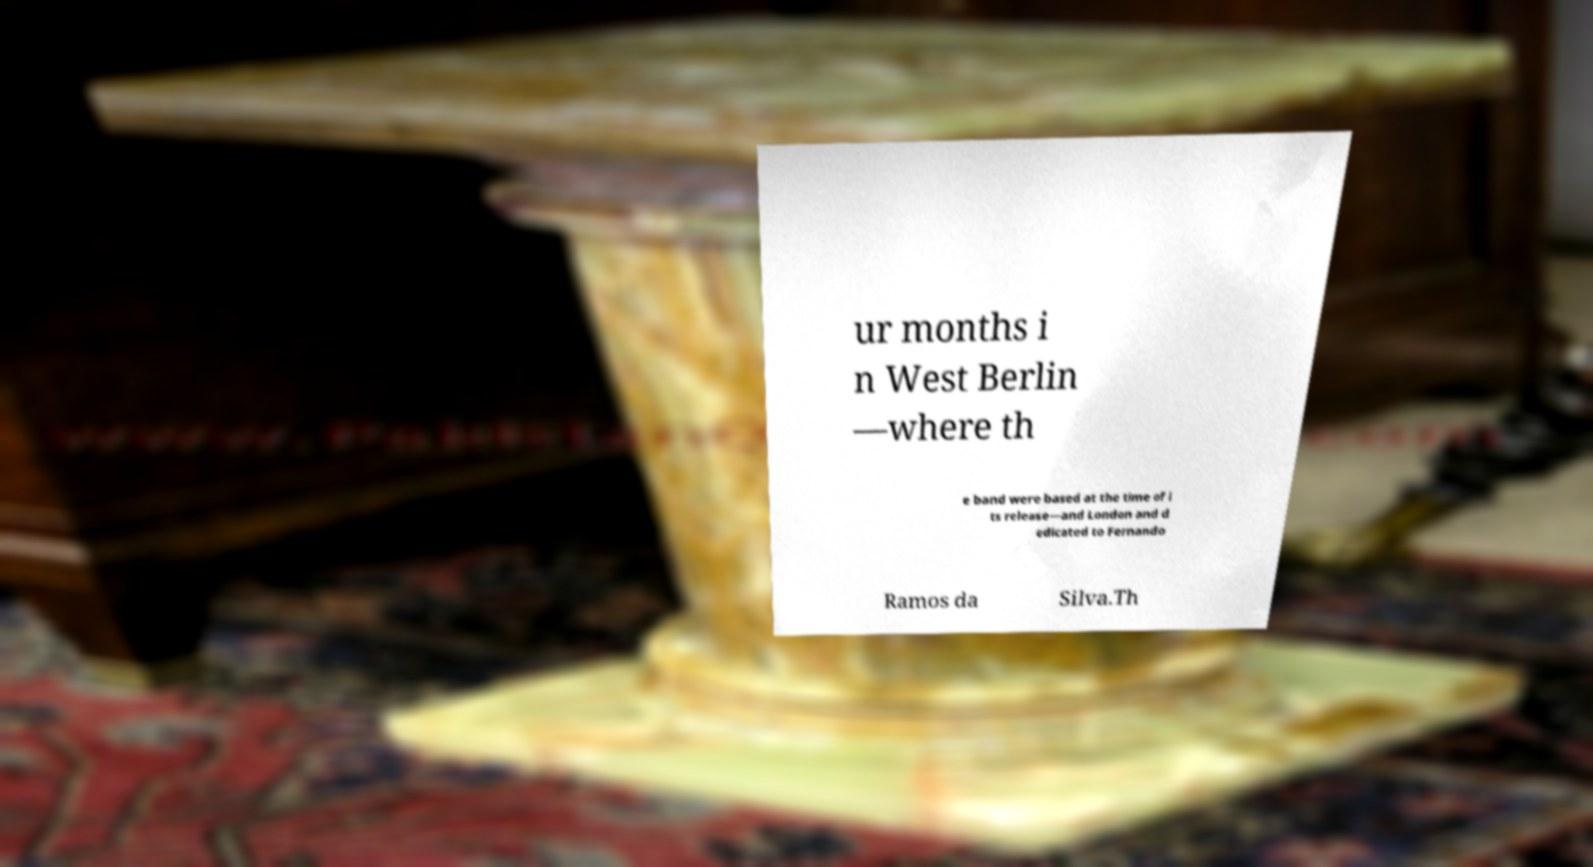Please identify and transcribe the text found in this image. ur months i n West Berlin —where th e band were based at the time of i ts release—and London and d edicated to Fernando Ramos da Silva.Th 